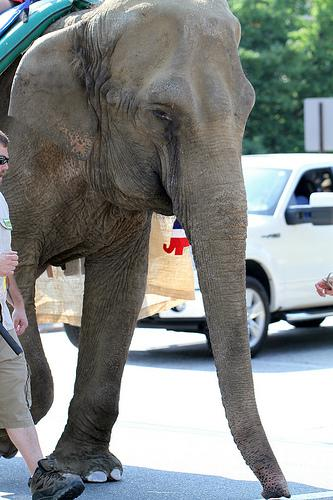Question: where was this taken?
Choices:
A. On a beach.
B. On a street.
C. In the park.
D. On a rollercoaster.
Answer with the letter. Answer: B Question: what is this animal?
Choices:
A. A giraffe.
B. A bear.
C. An elephant.
D. A tiger.
Answer with the letter. Answer: C Question: who is walking beside the elephant?
Choices:
A. A woman.
B. A girl.
C. A boy.
D. A man.
Answer with the letter. Answer: D Question: when was this picture taken?
Choices:
A. At night.
B. Before dawn.
C. Early evening.
D. During the day.
Answer with the letter. Answer: D Question: how many elephants are there?
Choices:
A. 2.
B. 3.
C. 1.
D. 4.
Answer with the letter. Answer: C Question: what color is the elephant?
Choices:
A. Black.
B. White.
C. Grey.
D. Silver.
Answer with the letter. Answer: C 